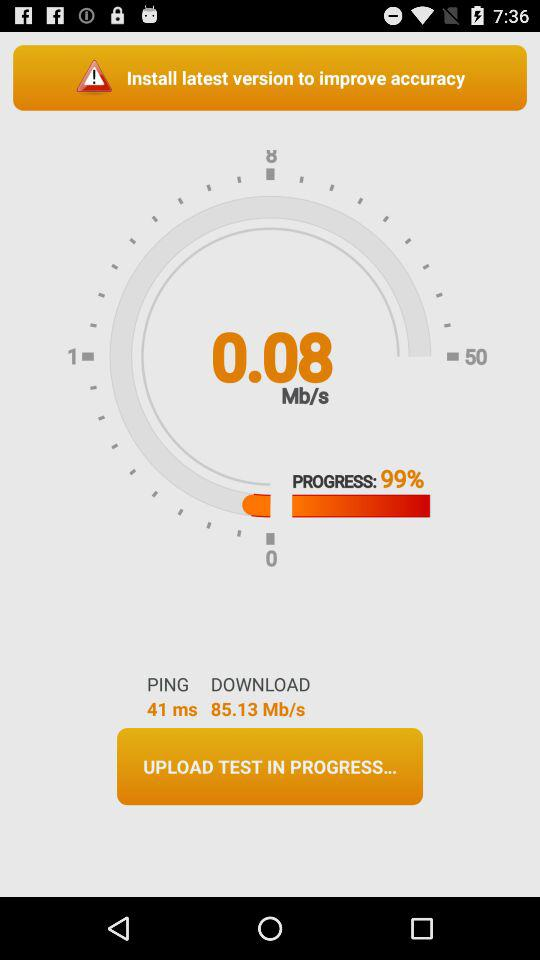How much is the Mb/s at 100% progress?
When the provided information is insufficient, respond with <no answer>. <no answer> 